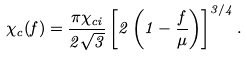Convert formula to latex. <formula><loc_0><loc_0><loc_500><loc_500>\chi _ { c } ( f ) = \frac { \pi \chi _ { c i } } { 2 \sqrt { 3 } } \left [ 2 \left ( 1 - \frac { f } { \mu } \right ) \right ] ^ { 3 / 4 } .</formula> 